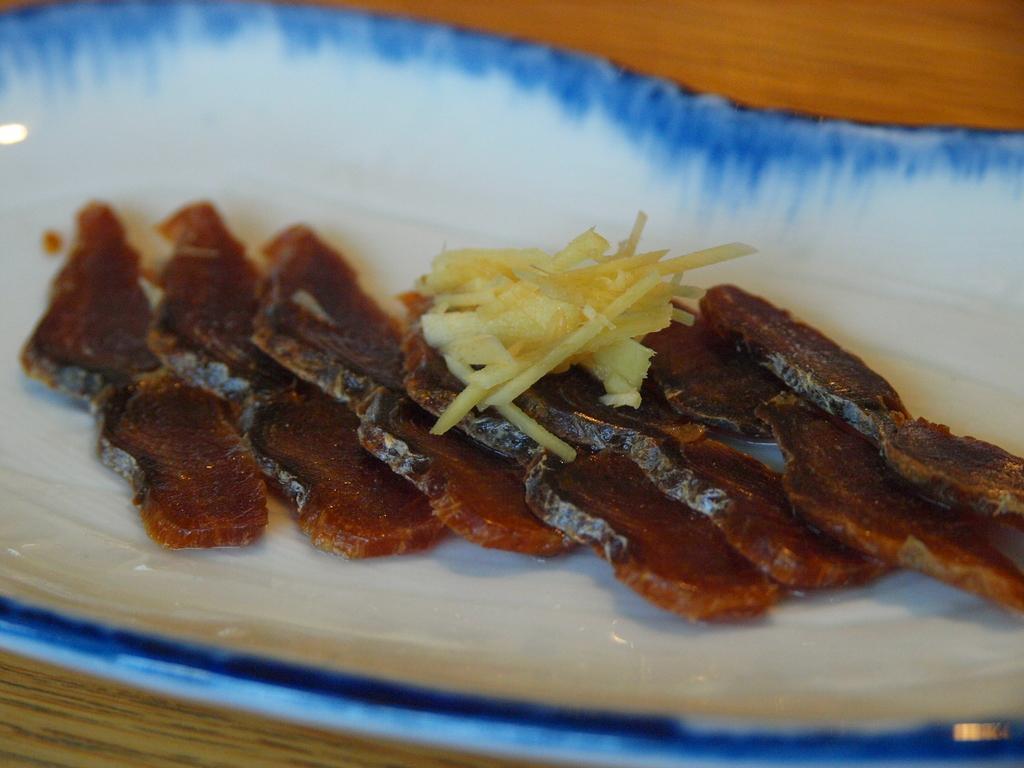In one or two sentences, can you explain what this image depicts? In the foreground of this picture, there is some food and cheese on a plate which is placed on a table. 